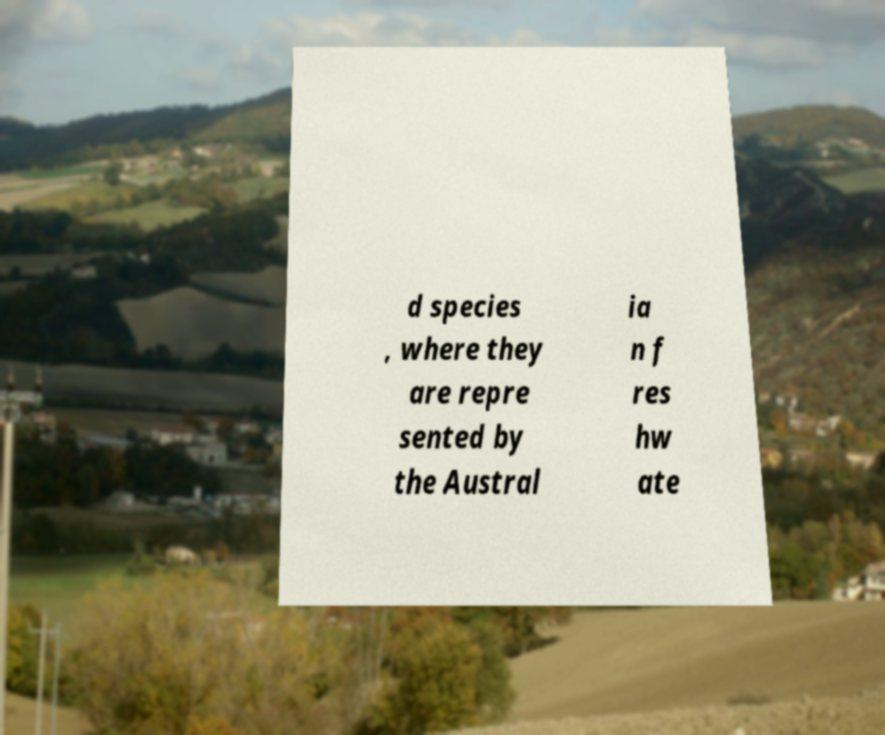There's text embedded in this image that I need extracted. Can you transcribe it verbatim? d species , where they are repre sented by the Austral ia n f res hw ate 